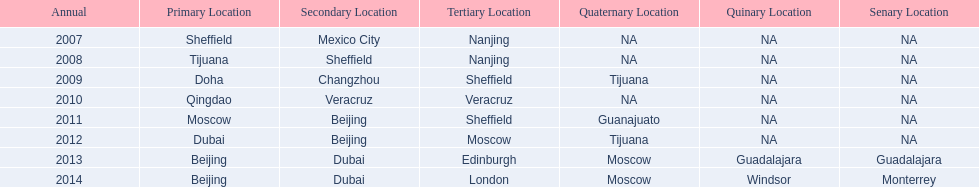In what year was the 3rd venue the same as 2011's 1st venue? 2012. 